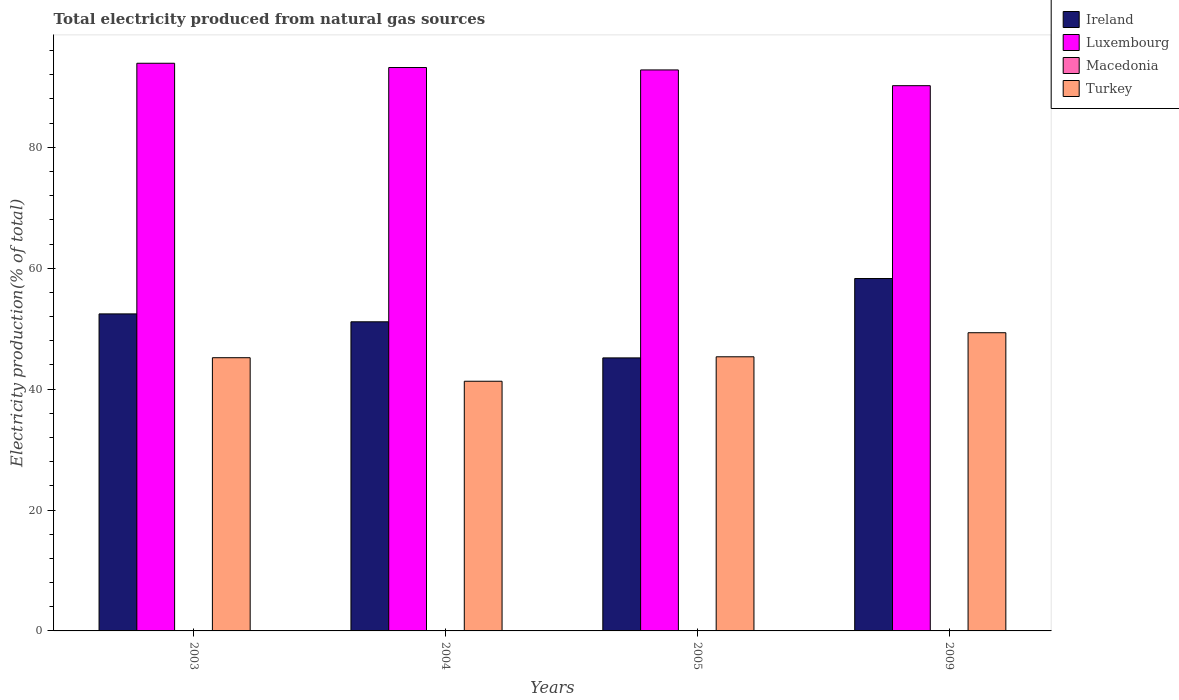Are the number of bars per tick equal to the number of legend labels?
Your response must be concise. Yes. What is the label of the 3rd group of bars from the left?
Make the answer very short. 2005. What is the total electricity produced in Macedonia in 2004?
Your response must be concise. 0.01. Across all years, what is the maximum total electricity produced in Macedonia?
Offer a terse response. 0.03. Across all years, what is the minimum total electricity produced in Turkey?
Your answer should be very brief. 41.3. In which year was the total electricity produced in Luxembourg maximum?
Offer a very short reply. 2003. What is the total total electricity produced in Ireland in the graph?
Your answer should be compact. 207.04. What is the difference between the total electricity produced in Macedonia in 2004 and that in 2005?
Provide a short and direct response. 0. What is the difference between the total electricity produced in Ireland in 2009 and the total electricity produced in Luxembourg in 2004?
Provide a short and direct response. -34.9. What is the average total electricity produced in Macedonia per year?
Give a very brief answer. 0.02. In the year 2004, what is the difference between the total electricity produced in Luxembourg and total electricity produced in Macedonia?
Your answer should be compact. 93.18. In how many years, is the total electricity produced in Ireland greater than 68 %?
Your answer should be compact. 0. What is the ratio of the total electricity produced in Turkey in 2003 to that in 2005?
Keep it short and to the point. 1. Is the total electricity produced in Macedonia in 2005 less than that in 2009?
Give a very brief answer. Yes. Is the difference between the total electricity produced in Luxembourg in 2003 and 2005 greater than the difference between the total electricity produced in Macedonia in 2003 and 2005?
Keep it short and to the point. Yes. What is the difference between the highest and the second highest total electricity produced in Luxembourg?
Offer a very short reply. 0.71. What is the difference between the highest and the lowest total electricity produced in Luxembourg?
Ensure brevity in your answer.  3.71. Is the sum of the total electricity produced in Luxembourg in 2003 and 2004 greater than the maximum total electricity produced in Turkey across all years?
Your answer should be very brief. Yes. What does the 4th bar from the left in 2009 represents?
Keep it short and to the point. Turkey. What does the 1st bar from the right in 2005 represents?
Provide a short and direct response. Turkey. Is it the case that in every year, the sum of the total electricity produced in Luxembourg and total electricity produced in Ireland is greater than the total electricity produced in Macedonia?
Keep it short and to the point. Yes. Are all the bars in the graph horizontal?
Give a very brief answer. No. How many years are there in the graph?
Keep it short and to the point. 4. Are the values on the major ticks of Y-axis written in scientific E-notation?
Your answer should be compact. No. Does the graph contain any zero values?
Offer a very short reply. No. Where does the legend appear in the graph?
Your response must be concise. Top right. How many legend labels are there?
Your answer should be very brief. 4. How are the legend labels stacked?
Provide a succinct answer. Vertical. What is the title of the graph?
Offer a very short reply. Total electricity produced from natural gas sources. Does "American Samoa" appear as one of the legend labels in the graph?
Your answer should be compact. No. What is the label or title of the X-axis?
Provide a short and direct response. Years. What is the label or title of the Y-axis?
Your answer should be compact. Electricity production(% of total). What is the Electricity production(% of total) of Ireland in 2003?
Your response must be concise. 52.44. What is the Electricity production(% of total) in Luxembourg in 2003?
Give a very brief answer. 93.9. What is the Electricity production(% of total) of Macedonia in 2003?
Offer a very short reply. 0.01. What is the Electricity production(% of total) of Turkey in 2003?
Give a very brief answer. 45.2. What is the Electricity production(% of total) in Ireland in 2004?
Your response must be concise. 51.14. What is the Electricity production(% of total) in Luxembourg in 2004?
Your response must be concise. 93.2. What is the Electricity production(% of total) of Macedonia in 2004?
Offer a terse response. 0.01. What is the Electricity production(% of total) in Turkey in 2004?
Ensure brevity in your answer.  41.3. What is the Electricity production(% of total) in Ireland in 2005?
Give a very brief answer. 45.17. What is the Electricity production(% of total) in Luxembourg in 2005?
Provide a short and direct response. 92.8. What is the Electricity production(% of total) in Macedonia in 2005?
Provide a succinct answer. 0.01. What is the Electricity production(% of total) in Turkey in 2005?
Ensure brevity in your answer.  45.35. What is the Electricity production(% of total) in Ireland in 2009?
Provide a short and direct response. 58.29. What is the Electricity production(% of total) in Luxembourg in 2009?
Provide a short and direct response. 90.2. What is the Electricity production(% of total) of Macedonia in 2009?
Offer a terse response. 0.03. What is the Electricity production(% of total) of Turkey in 2009?
Your response must be concise. 49.33. Across all years, what is the maximum Electricity production(% of total) in Ireland?
Offer a terse response. 58.29. Across all years, what is the maximum Electricity production(% of total) of Luxembourg?
Ensure brevity in your answer.  93.9. Across all years, what is the maximum Electricity production(% of total) in Macedonia?
Your response must be concise. 0.03. Across all years, what is the maximum Electricity production(% of total) in Turkey?
Provide a short and direct response. 49.33. Across all years, what is the minimum Electricity production(% of total) in Ireland?
Offer a very short reply. 45.17. Across all years, what is the minimum Electricity production(% of total) of Luxembourg?
Your response must be concise. 90.2. Across all years, what is the minimum Electricity production(% of total) in Macedonia?
Your answer should be compact. 0.01. Across all years, what is the minimum Electricity production(% of total) in Turkey?
Give a very brief answer. 41.3. What is the total Electricity production(% of total) in Ireland in the graph?
Offer a very short reply. 207.04. What is the total Electricity production(% of total) in Luxembourg in the graph?
Your response must be concise. 370.1. What is the total Electricity production(% of total) in Macedonia in the graph?
Your answer should be very brief. 0.07. What is the total Electricity production(% of total) in Turkey in the graph?
Provide a succinct answer. 181.17. What is the difference between the Electricity production(% of total) of Ireland in 2003 and that in 2004?
Make the answer very short. 1.31. What is the difference between the Electricity production(% of total) in Luxembourg in 2003 and that in 2004?
Your answer should be very brief. 0.71. What is the difference between the Electricity production(% of total) in Macedonia in 2003 and that in 2004?
Provide a short and direct response. -0. What is the difference between the Electricity production(% of total) of Turkey in 2003 and that in 2004?
Ensure brevity in your answer.  3.89. What is the difference between the Electricity production(% of total) in Ireland in 2003 and that in 2005?
Make the answer very short. 7.28. What is the difference between the Electricity production(% of total) of Luxembourg in 2003 and that in 2005?
Your answer should be compact. 1.1. What is the difference between the Electricity production(% of total) in Macedonia in 2003 and that in 2005?
Provide a short and direct response. 0. What is the difference between the Electricity production(% of total) of Turkey in 2003 and that in 2005?
Ensure brevity in your answer.  -0.15. What is the difference between the Electricity production(% of total) in Ireland in 2003 and that in 2009?
Provide a succinct answer. -5.85. What is the difference between the Electricity production(% of total) of Luxembourg in 2003 and that in 2009?
Provide a succinct answer. 3.71. What is the difference between the Electricity production(% of total) of Macedonia in 2003 and that in 2009?
Offer a very short reply. -0.01. What is the difference between the Electricity production(% of total) in Turkey in 2003 and that in 2009?
Your answer should be compact. -4.13. What is the difference between the Electricity production(% of total) in Ireland in 2004 and that in 2005?
Your answer should be compact. 5.97. What is the difference between the Electricity production(% of total) of Luxembourg in 2004 and that in 2005?
Offer a very short reply. 0.4. What is the difference between the Electricity production(% of total) of Macedonia in 2004 and that in 2005?
Your answer should be compact. 0. What is the difference between the Electricity production(% of total) in Turkey in 2004 and that in 2005?
Keep it short and to the point. -4.05. What is the difference between the Electricity production(% of total) in Ireland in 2004 and that in 2009?
Keep it short and to the point. -7.16. What is the difference between the Electricity production(% of total) of Luxembourg in 2004 and that in 2009?
Provide a short and direct response. 3. What is the difference between the Electricity production(% of total) of Macedonia in 2004 and that in 2009?
Provide a succinct answer. -0.01. What is the difference between the Electricity production(% of total) in Turkey in 2004 and that in 2009?
Provide a short and direct response. -8.03. What is the difference between the Electricity production(% of total) in Ireland in 2005 and that in 2009?
Offer a very short reply. -13.13. What is the difference between the Electricity production(% of total) of Luxembourg in 2005 and that in 2009?
Offer a terse response. 2.6. What is the difference between the Electricity production(% of total) in Macedonia in 2005 and that in 2009?
Offer a very short reply. -0.01. What is the difference between the Electricity production(% of total) in Turkey in 2005 and that in 2009?
Provide a succinct answer. -3.98. What is the difference between the Electricity production(% of total) of Ireland in 2003 and the Electricity production(% of total) of Luxembourg in 2004?
Make the answer very short. -40.76. What is the difference between the Electricity production(% of total) in Ireland in 2003 and the Electricity production(% of total) in Macedonia in 2004?
Provide a short and direct response. 52.43. What is the difference between the Electricity production(% of total) of Ireland in 2003 and the Electricity production(% of total) of Turkey in 2004?
Your response must be concise. 11.14. What is the difference between the Electricity production(% of total) in Luxembourg in 2003 and the Electricity production(% of total) in Macedonia in 2004?
Offer a very short reply. 93.89. What is the difference between the Electricity production(% of total) in Luxembourg in 2003 and the Electricity production(% of total) in Turkey in 2004?
Ensure brevity in your answer.  52.6. What is the difference between the Electricity production(% of total) in Macedonia in 2003 and the Electricity production(% of total) in Turkey in 2004?
Provide a short and direct response. -41.29. What is the difference between the Electricity production(% of total) of Ireland in 2003 and the Electricity production(% of total) of Luxembourg in 2005?
Offer a terse response. -40.36. What is the difference between the Electricity production(% of total) of Ireland in 2003 and the Electricity production(% of total) of Macedonia in 2005?
Offer a terse response. 52.43. What is the difference between the Electricity production(% of total) in Ireland in 2003 and the Electricity production(% of total) in Turkey in 2005?
Provide a succinct answer. 7.09. What is the difference between the Electricity production(% of total) in Luxembourg in 2003 and the Electricity production(% of total) in Macedonia in 2005?
Offer a very short reply. 93.89. What is the difference between the Electricity production(% of total) of Luxembourg in 2003 and the Electricity production(% of total) of Turkey in 2005?
Keep it short and to the point. 48.56. What is the difference between the Electricity production(% of total) of Macedonia in 2003 and the Electricity production(% of total) of Turkey in 2005?
Ensure brevity in your answer.  -45.33. What is the difference between the Electricity production(% of total) in Ireland in 2003 and the Electricity production(% of total) in Luxembourg in 2009?
Offer a terse response. -37.75. What is the difference between the Electricity production(% of total) in Ireland in 2003 and the Electricity production(% of total) in Macedonia in 2009?
Give a very brief answer. 52.41. What is the difference between the Electricity production(% of total) in Ireland in 2003 and the Electricity production(% of total) in Turkey in 2009?
Your response must be concise. 3.12. What is the difference between the Electricity production(% of total) in Luxembourg in 2003 and the Electricity production(% of total) in Macedonia in 2009?
Your response must be concise. 93.88. What is the difference between the Electricity production(% of total) in Luxembourg in 2003 and the Electricity production(% of total) in Turkey in 2009?
Offer a very short reply. 44.58. What is the difference between the Electricity production(% of total) in Macedonia in 2003 and the Electricity production(% of total) in Turkey in 2009?
Give a very brief answer. -49.31. What is the difference between the Electricity production(% of total) in Ireland in 2004 and the Electricity production(% of total) in Luxembourg in 2005?
Offer a terse response. -41.67. What is the difference between the Electricity production(% of total) of Ireland in 2004 and the Electricity production(% of total) of Macedonia in 2005?
Your response must be concise. 51.12. What is the difference between the Electricity production(% of total) of Ireland in 2004 and the Electricity production(% of total) of Turkey in 2005?
Provide a succinct answer. 5.79. What is the difference between the Electricity production(% of total) in Luxembourg in 2004 and the Electricity production(% of total) in Macedonia in 2005?
Give a very brief answer. 93.18. What is the difference between the Electricity production(% of total) of Luxembourg in 2004 and the Electricity production(% of total) of Turkey in 2005?
Your answer should be compact. 47.85. What is the difference between the Electricity production(% of total) in Macedonia in 2004 and the Electricity production(% of total) in Turkey in 2005?
Keep it short and to the point. -45.33. What is the difference between the Electricity production(% of total) in Ireland in 2004 and the Electricity production(% of total) in Luxembourg in 2009?
Ensure brevity in your answer.  -39.06. What is the difference between the Electricity production(% of total) of Ireland in 2004 and the Electricity production(% of total) of Macedonia in 2009?
Ensure brevity in your answer.  51.11. What is the difference between the Electricity production(% of total) of Ireland in 2004 and the Electricity production(% of total) of Turkey in 2009?
Keep it short and to the point. 1.81. What is the difference between the Electricity production(% of total) of Luxembourg in 2004 and the Electricity production(% of total) of Macedonia in 2009?
Give a very brief answer. 93.17. What is the difference between the Electricity production(% of total) of Luxembourg in 2004 and the Electricity production(% of total) of Turkey in 2009?
Provide a short and direct response. 43.87. What is the difference between the Electricity production(% of total) in Macedonia in 2004 and the Electricity production(% of total) in Turkey in 2009?
Your answer should be compact. -49.31. What is the difference between the Electricity production(% of total) in Ireland in 2005 and the Electricity production(% of total) in Luxembourg in 2009?
Make the answer very short. -45.03. What is the difference between the Electricity production(% of total) of Ireland in 2005 and the Electricity production(% of total) of Macedonia in 2009?
Keep it short and to the point. 45.14. What is the difference between the Electricity production(% of total) in Ireland in 2005 and the Electricity production(% of total) in Turkey in 2009?
Offer a very short reply. -4.16. What is the difference between the Electricity production(% of total) in Luxembourg in 2005 and the Electricity production(% of total) in Macedonia in 2009?
Your answer should be compact. 92.77. What is the difference between the Electricity production(% of total) of Luxembourg in 2005 and the Electricity production(% of total) of Turkey in 2009?
Ensure brevity in your answer.  43.47. What is the difference between the Electricity production(% of total) of Macedonia in 2005 and the Electricity production(% of total) of Turkey in 2009?
Make the answer very short. -49.31. What is the average Electricity production(% of total) of Ireland per year?
Your response must be concise. 51.76. What is the average Electricity production(% of total) in Luxembourg per year?
Give a very brief answer. 92.53. What is the average Electricity production(% of total) of Macedonia per year?
Offer a terse response. 0.02. What is the average Electricity production(% of total) in Turkey per year?
Your answer should be very brief. 45.29. In the year 2003, what is the difference between the Electricity production(% of total) of Ireland and Electricity production(% of total) of Luxembourg?
Make the answer very short. -41.46. In the year 2003, what is the difference between the Electricity production(% of total) in Ireland and Electricity production(% of total) in Macedonia?
Make the answer very short. 52.43. In the year 2003, what is the difference between the Electricity production(% of total) of Ireland and Electricity production(% of total) of Turkey?
Keep it short and to the point. 7.25. In the year 2003, what is the difference between the Electricity production(% of total) in Luxembourg and Electricity production(% of total) in Macedonia?
Your answer should be compact. 93.89. In the year 2003, what is the difference between the Electricity production(% of total) in Luxembourg and Electricity production(% of total) in Turkey?
Your response must be concise. 48.71. In the year 2003, what is the difference between the Electricity production(% of total) in Macedonia and Electricity production(% of total) in Turkey?
Your answer should be very brief. -45.18. In the year 2004, what is the difference between the Electricity production(% of total) in Ireland and Electricity production(% of total) in Luxembourg?
Your response must be concise. -42.06. In the year 2004, what is the difference between the Electricity production(% of total) of Ireland and Electricity production(% of total) of Macedonia?
Give a very brief answer. 51.12. In the year 2004, what is the difference between the Electricity production(% of total) of Ireland and Electricity production(% of total) of Turkey?
Your answer should be compact. 9.83. In the year 2004, what is the difference between the Electricity production(% of total) in Luxembourg and Electricity production(% of total) in Macedonia?
Your answer should be compact. 93.18. In the year 2004, what is the difference between the Electricity production(% of total) in Luxembourg and Electricity production(% of total) in Turkey?
Your response must be concise. 51.9. In the year 2004, what is the difference between the Electricity production(% of total) in Macedonia and Electricity production(% of total) in Turkey?
Ensure brevity in your answer.  -41.29. In the year 2005, what is the difference between the Electricity production(% of total) of Ireland and Electricity production(% of total) of Luxembourg?
Your answer should be very brief. -47.64. In the year 2005, what is the difference between the Electricity production(% of total) of Ireland and Electricity production(% of total) of Macedonia?
Keep it short and to the point. 45.15. In the year 2005, what is the difference between the Electricity production(% of total) of Ireland and Electricity production(% of total) of Turkey?
Ensure brevity in your answer.  -0.18. In the year 2005, what is the difference between the Electricity production(% of total) in Luxembourg and Electricity production(% of total) in Macedonia?
Provide a succinct answer. 92.79. In the year 2005, what is the difference between the Electricity production(% of total) of Luxembourg and Electricity production(% of total) of Turkey?
Your answer should be very brief. 47.45. In the year 2005, what is the difference between the Electricity production(% of total) in Macedonia and Electricity production(% of total) in Turkey?
Your answer should be compact. -45.33. In the year 2009, what is the difference between the Electricity production(% of total) of Ireland and Electricity production(% of total) of Luxembourg?
Provide a succinct answer. -31.9. In the year 2009, what is the difference between the Electricity production(% of total) of Ireland and Electricity production(% of total) of Macedonia?
Ensure brevity in your answer.  58.27. In the year 2009, what is the difference between the Electricity production(% of total) in Ireland and Electricity production(% of total) in Turkey?
Your answer should be compact. 8.97. In the year 2009, what is the difference between the Electricity production(% of total) of Luxembourg and Electricity production(% of total) of Macedonia?
Ensure brevity in your answer.  90.17. In the year 2009, what is the difference between the Electricity production(% of total) of Luxembourg and Electricity production(% of total) of Turkey?
Give a very brief answer. 40.87. In the year 2009, what is the difference between the Electricity production(% of total) in Macedonia and Electricity production(% of total) in Turkey?
Offer a terse response. -49.3. What is the ratio of the Electricity production(% of total) in Ireland in 2003 to that in 2004?
Provide a succinct answer. 1.03. What is the ratio of the Electricity production(% of total) of Luxembourg in 2003 to that in 2004?
Your response must be concise. 1.01. What is the ratio of the Electricity production(% of total) of Turkey in 2003 to that in 2004?
Provide a short and direct response. 1.09. What is the ratio of the Electricity production(% of total) in Ireland in 2003 to that in 2005?
Ensure brevity in your answer.  1.16. What is the ratio of the Electricity production(% of total) of Luxembourg in 2003 to that in 2005?
Your answer should be compact. 1.01. What is the ratio of the Electricity production(% of total) of Macedonia in 2003 to that in 2005?
Your answer should be compact. 1.03. What is the ratio of the Electricity production(% of total) of Turkey in 2003 to that in 2005?
Make the answer very short. 1. What is the ratio of the Electricity production(% of total) in Ireland in 2003 to that in 2009?
Your answer should be compact. 0.9. What is the ratio of the Electricity production(% of total) of Luxembourg in 2003 to that in 2009?
Make the answer very short. 1.04. What is the ratio of the Electricity production(% of total) in Macedonia in 2003 to that in 2009?
Your answer should be compact. 0.51. What is the ratio of the Electricity production(% of total) in Turkey in 2003 to that in 2009?
Provide a succinct answer. 0.92. What is the ratio of the Electricity production(% of total) in Ireland in 2004 to that in 2005?
Keep it short and to the point. 1.13. What is the ratio of the Electricity production(% of total) in Macedonia in 2004 to that in 2005?
Keep it short and to the point. 1.04. What is the ratio of the Electricity production(% of total) in Turkey in 2004 to that in 2005?
Provide a succinct answer. 0.91. What is the ratio of the Electricity production(% of total) in Ireland in 2004 to that in 2009?
Offer a very short reply. 0.88. What is the ratio of the Electricity production(% of total) in Luxembourg in 2004 to that in 2009?
Offer a very short reply. 1.03. What is the ratio of the Electricity production(% of total) of Macedonia in 2004 to that in 2009?
Offer a terse response. 0.51. What is the ratio of the Electricity production(% of total) in Turkey in 2004 to that in 2009?
Offer a terse response. 0.84. What is the ratio of the Electricity production(% of total) in Ireland in 2005 to that in 2009?
Keep it short and to the point. 0.77. What is the ratio of the Electricity production(% of total) in Luxembourg in 2005 to that in 2009?
Your answer should be very brief. 1.03. What is the ratio of the Electricity production(% of total) of Macedonia in 2005 to that in 2009?
Offer a very short reply. 0.49. What is the ratio of the Electricity production(% of total) in Turkey in 2005 to that in 2009?
Your answer should be very brief. 0.92. What is the difference between the highest and the second highest Electricity production(% of total) in Ireland?
Ensure brevity in your answer.  5.85. What is the difference between the highest and the second highest Electricity production(% of total) of Luxembourg?
Your answer should be compact. 0.71. What is the difference between the highest and the second highest Electricity production(% of total) of Macedonia?
Your answer should be very brief. 0.01. What is the difference between the highest and the second highest Electricity production(% of total) of Turkey?
Provide a succinct answer. 3.98. What is the difference between the highest and the lowest Electricity production(% of total) of Ireland?
Your answer should be compact. 13.13. What is the difference between the highest and the lowest Electricity production(% of total) in Luxembourg?
Offer a very short reply. 3.71. What is the difference between the highest and the lowest Electricity production(% of total) in Macedonia?
Your answer should be compact. 0.01. What is the difference between the highest and the lowest Electricity production(% of total) in Turkey?
Provide a succinct answer. 8.03. 